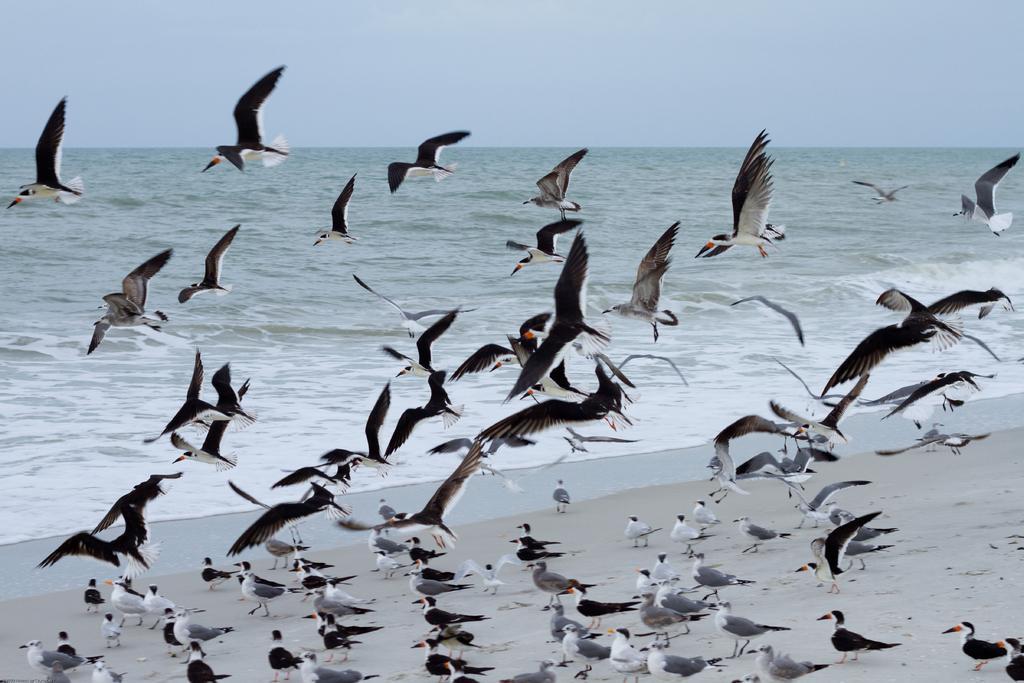Describe this image in one or two sentences. In this image we can see so many birds are in the air as well as on the land. In the background, we can see an ocean. At the top of the image, we can see the sky. 